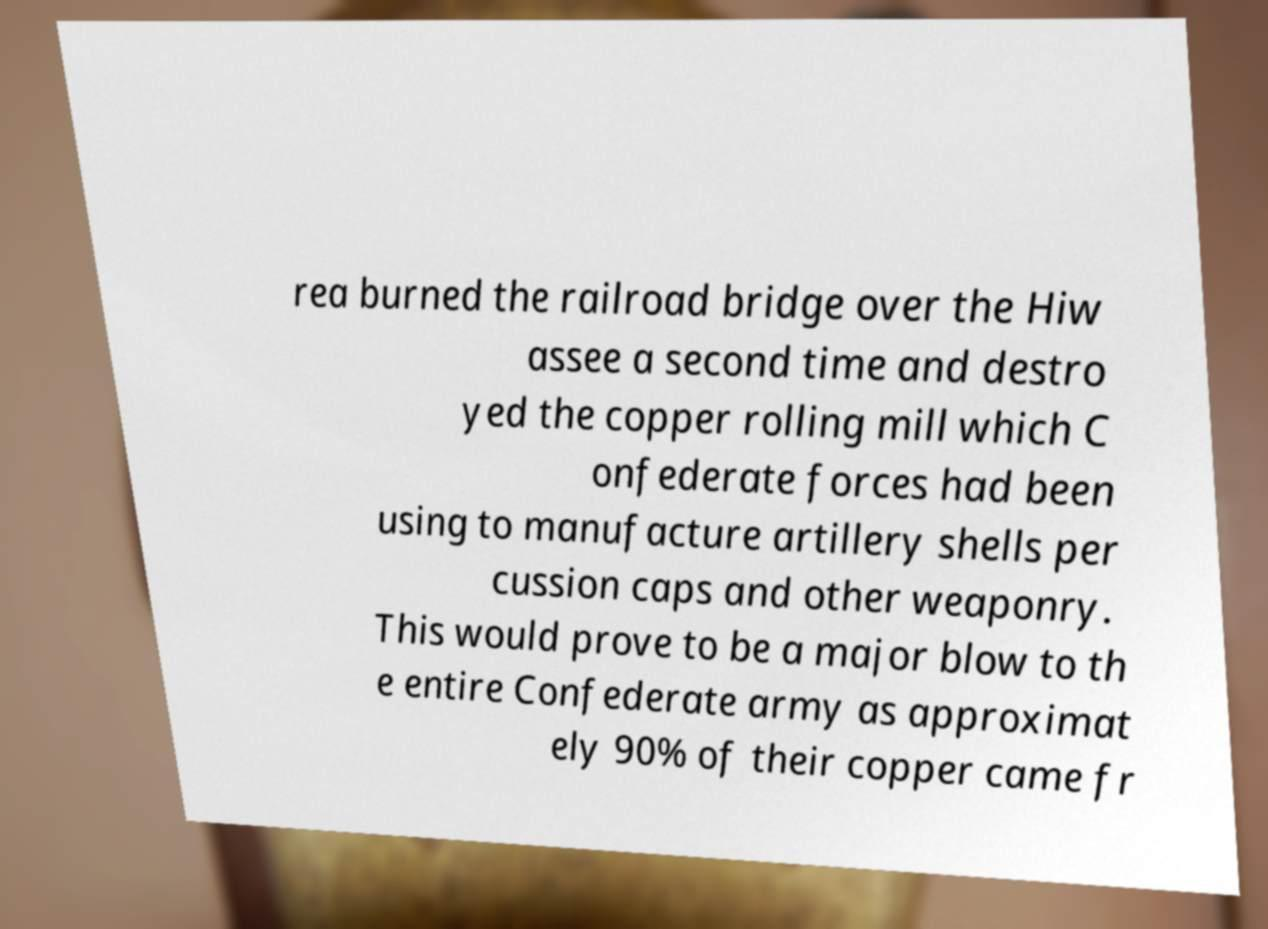Please identify and transcribe the text found in this image. rea burned the railroad bridge over the Hiw assee a second time and destro yed the copper rolling mill which C onfederate forces had been using to manufacture artillery shells per cussion caps and other weaponry. This would prove to be a major blow to th e entire Confederate army as approximat ely 90% of their copper came fr 